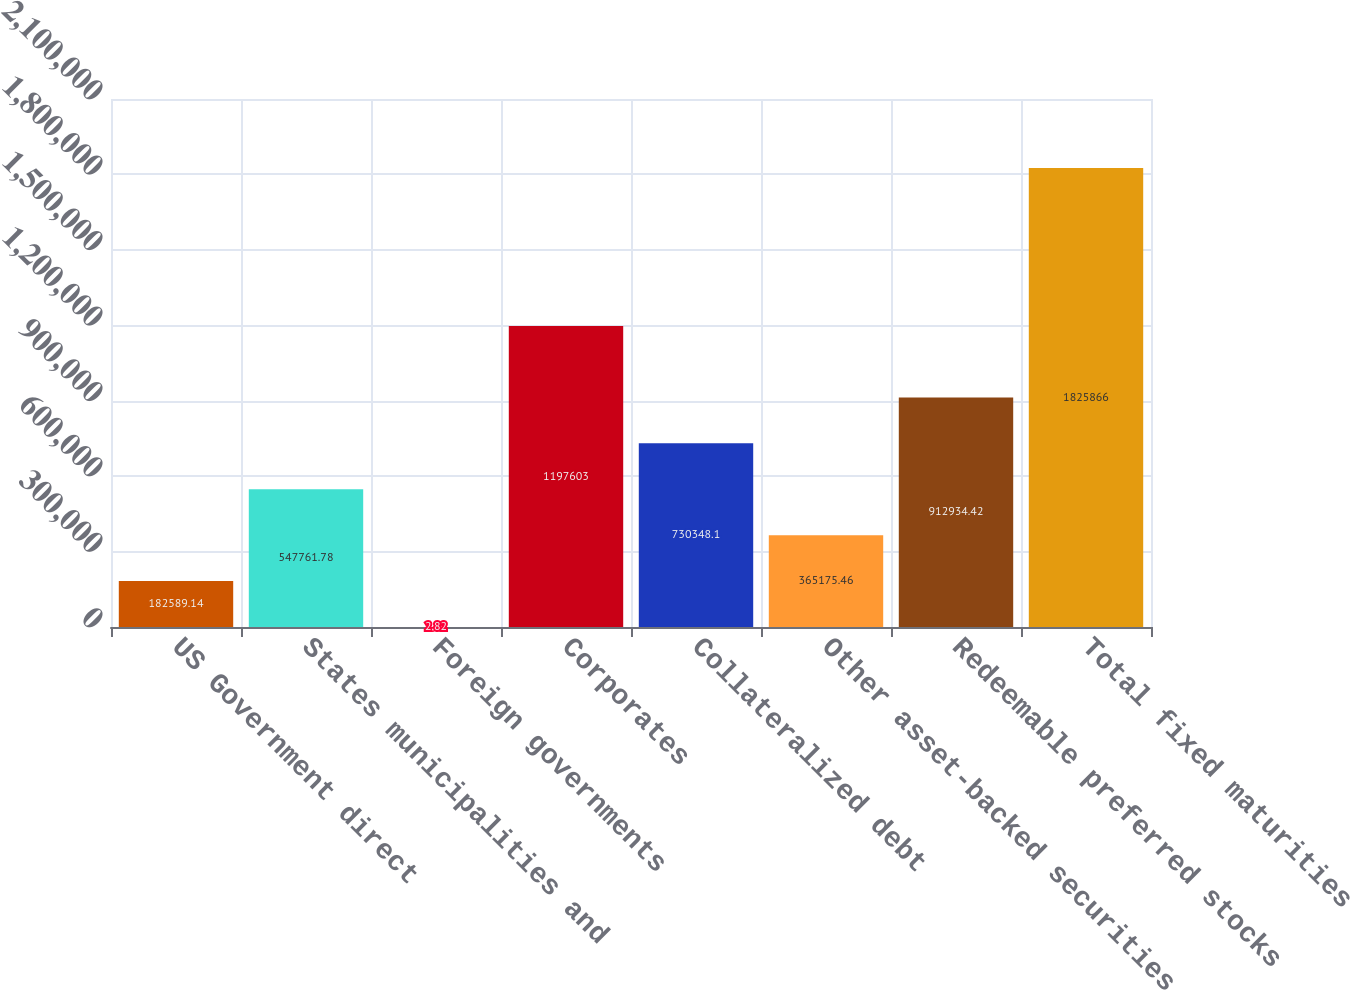<chart> <loc_0><loc_0><loc_500><loc_500><bar_chart><fcel>US Government direct<fcel>States municipalities and<fcel>Foreign governments<fcel>Corporates<fcel>Collateralized debt<fcel>Other asset-backed securities<fcel>Redeemable preferred stocks<fcel>Total fixed maturities<nl><fcel>182589<fcel>547762<fcel>2.82<fcel>1.1976e+06<fcel>730348<fcel>365175<fcel>912934<fcel>1.82587e+06<nl></chart> 